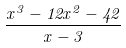Convert formula to latex. <formula><loc_0><loc_0><loc_500><loc_500>\frac { x ^ { 3 } - 1 2 x ^ { 2 } - 4 2 } { x - 3 }</formula> 